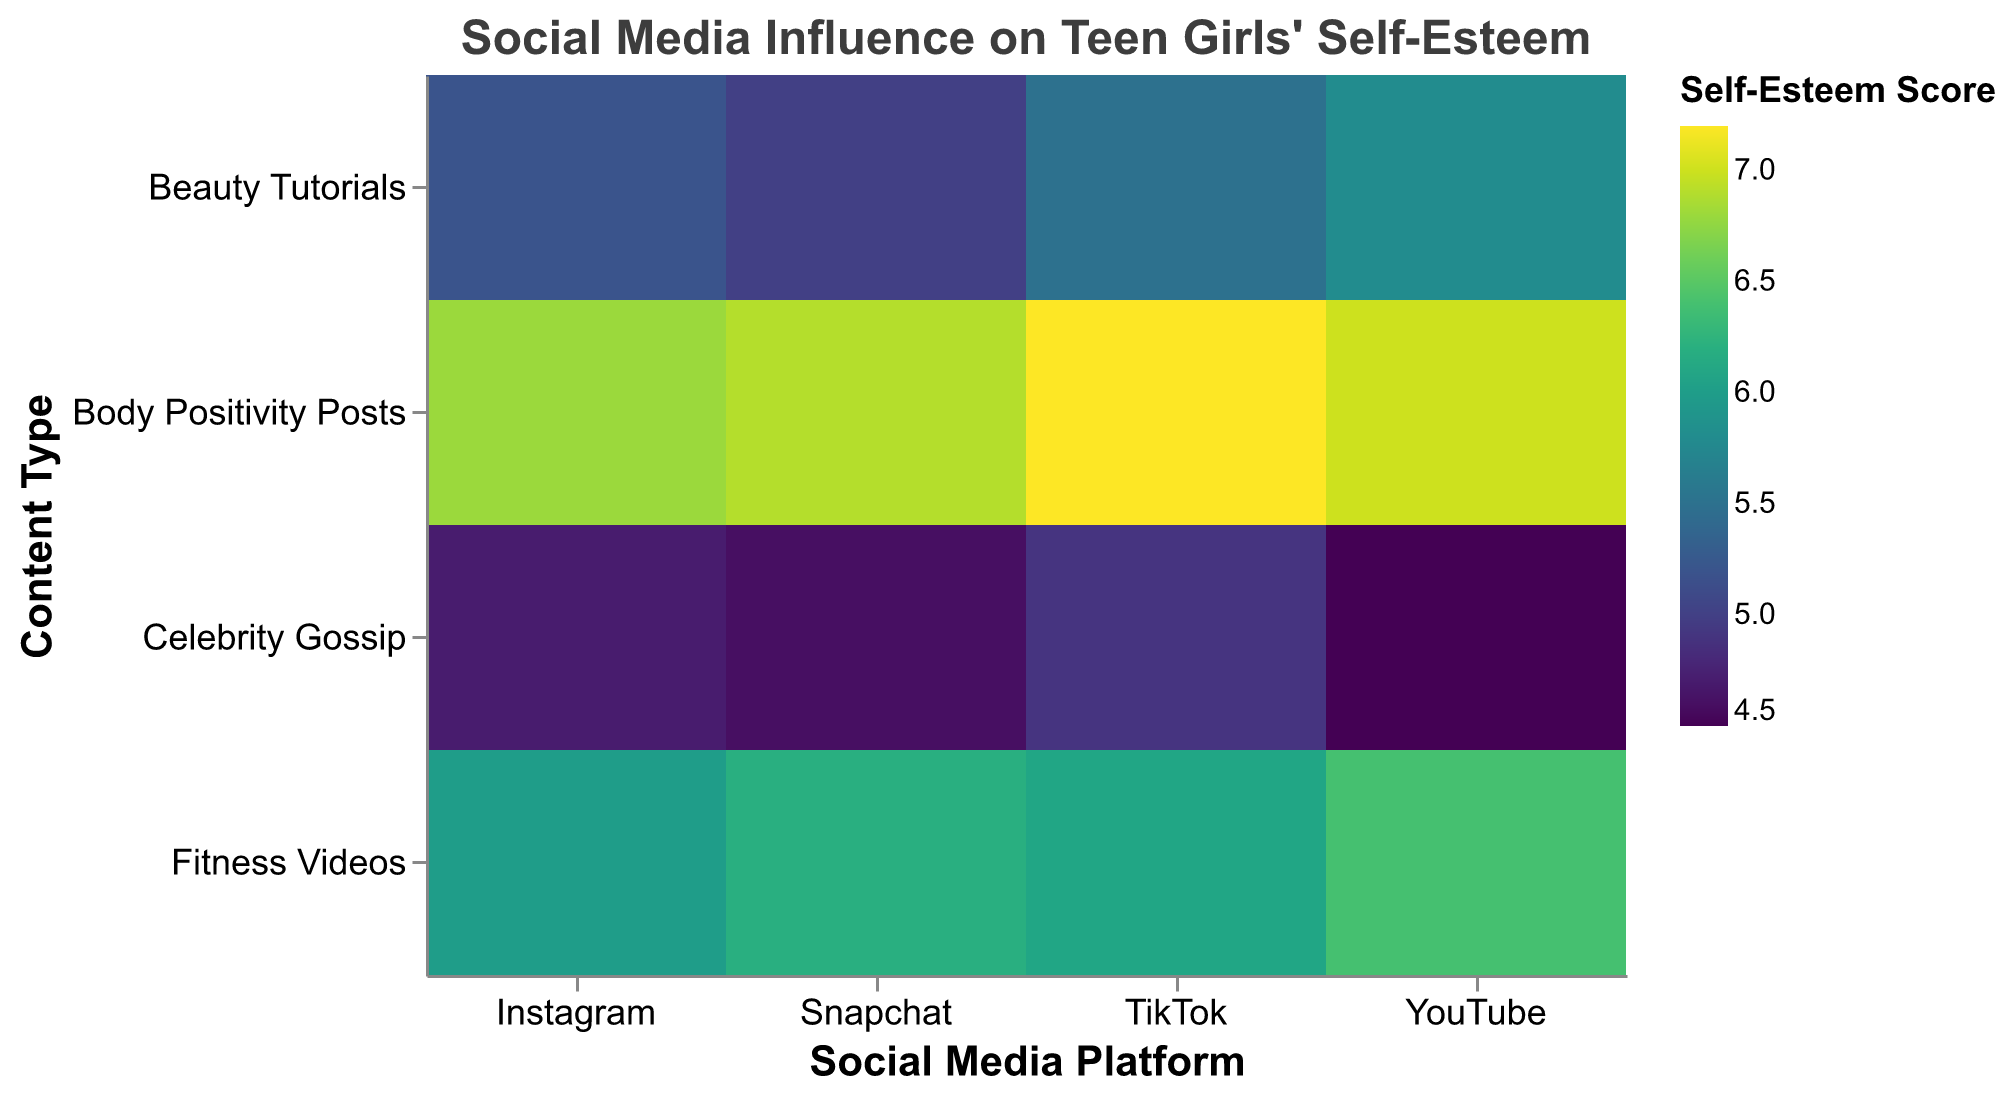What is the average self-esteem score for Body Positivity Posts on Instagram? To find the average self-esteem score, look at the "Instagram" row in the "Body Positivity Posts" column. The number there is 6.8.
Answer: 6.8 What is the highest self-esteem score recorded for any subcategory in the heatmap? The highest self-esteem score is 7.2, which is indicated by the color scale and seen in the "Body Positivity Posts" row for "TikTok".
Answer: 7.2 Which social media platform has the lowest average self-esteem score when it comes to Celebrity Gossip? Look at the "Celebrity Gossip" row and find the lowest number in that row. It's 4.5 on "YouTube".
Answer: YouTube Is the average self-esteem score for Fitness Videos higher on TikTok or Snapchat? Compare the numbers for "Fitness Videos" for both TikTok and Snapchat. TikTok has 6.1 and Snapchat has 6.2. 6.2 is higher.
Answer: Snapchat Which content type generally has higher self-esteem scores across all platforms, Beauty Tutorials or Body Positivity Posts? Compare the values across all platforms for "Beauty Tutorials" and "Body Positivity Posts". "Body Positivity Posts" consistently have higher scores.
Answer: Body Positivity Posts On which social media platform do the Beauty Tutorials have the highest self-esteem score? Compare the values for "Beauty Tutorials" across all platforms. YouTube has 5.8, which is the highest among the platforms.
Answer: YouTube What is the total time spent watching Fitness Videos across all platforms? Add the time spent for "Fitness Videos" on each platform: 45 (Instagram) + 50 (TikTok) + 60 (YouTube) + 30 (Snapchat) = 185 minutes/day.
Answer: 185 minutes/day What's the difference in self-esteem scores between Beauty Tutorials and Fitness Videos on Instagram? Subtract the self-esteem score for Beauty Tutorials from that of Fitness Videos on Instagram: 6.0 (Fitness Videos) - 5.2 (Beauty Tutorials) = 0.8.
Answer: 0.8 Which social media platform has the highest overall time spent watching videos? Sum the time spent for all content types on each platform and compare. Sum for Instagram = 30 + 45 + 20 + 35 = 130; TikTok = 25 + 50 + 15 + 40 = 130; YouTube = 40 + 60 + 25 + 45 = 170; Snapchat = 20 + 30 + 10 + 25 = 85. YouTube has the highest total time spent.
Answer: YouTube Do Body Positivity Posts on TikTok result in higher self-esteem compared to Fitness Videos on YouTube? Compare the self-esteem scores of Body Positivity Posts on TikTok (7.2) with that of Fitness Videos on YouTube (6.4). 7.2 is higher.
Answer: Yes 